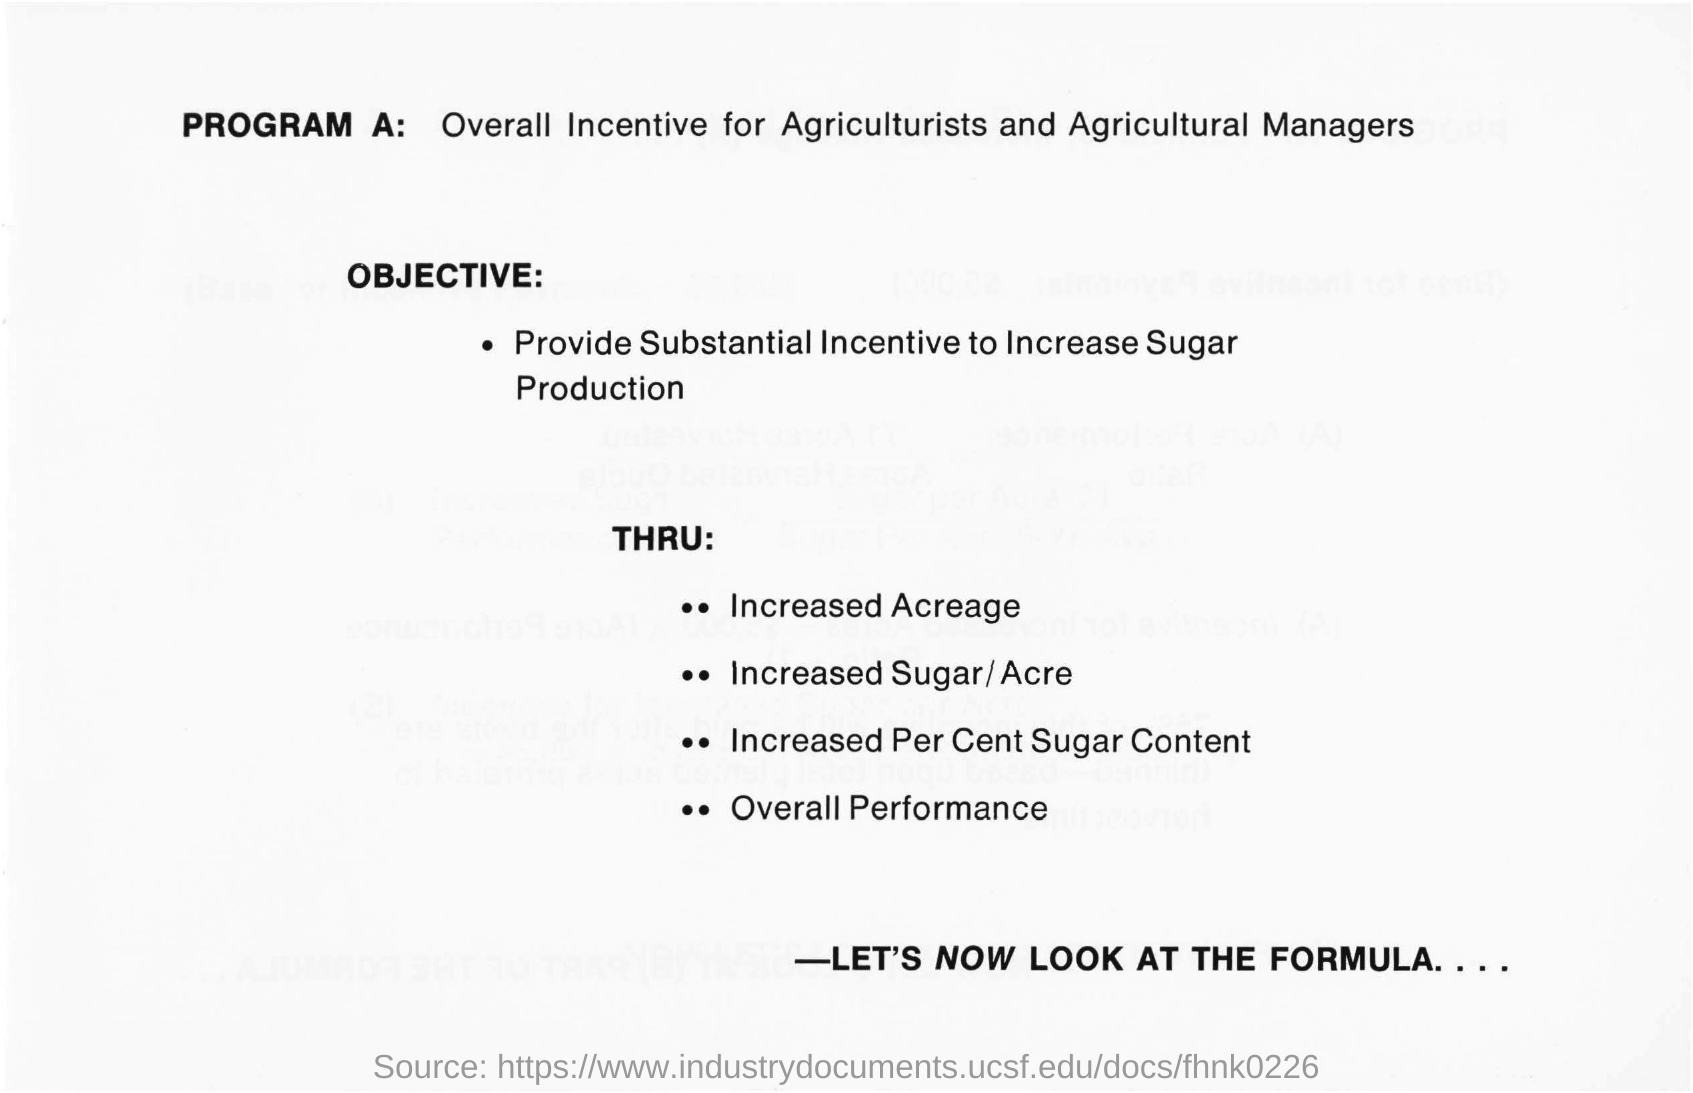What is program a?
Give a very brief answer. Overall incentive for agriculturists and agricultural managers. What is the objective?
Offer a terse response. PROVIDE SUBSTANTIAL INCENTIVE TO INCREASE SUGAR PRODUCTION. 